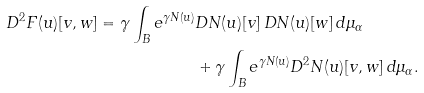<formula> <loc_0><loc_0><loc_500><loc_500>D ^ { 2 } F ( u ) [ v , w ] = \gamma \int _ { B } e ^ { \gamma N ( u ) } & D N ( u ) [ v ] \, D N ( u ) [ w ] \, d \mu _ { \alpha } \\ & + \gamma \int _ { B } e ^ { \gamma N ( u ) } D ^ { 2 } N ( u ) [ v , w ] \, d \mu _ { \alpha } .</formula> 